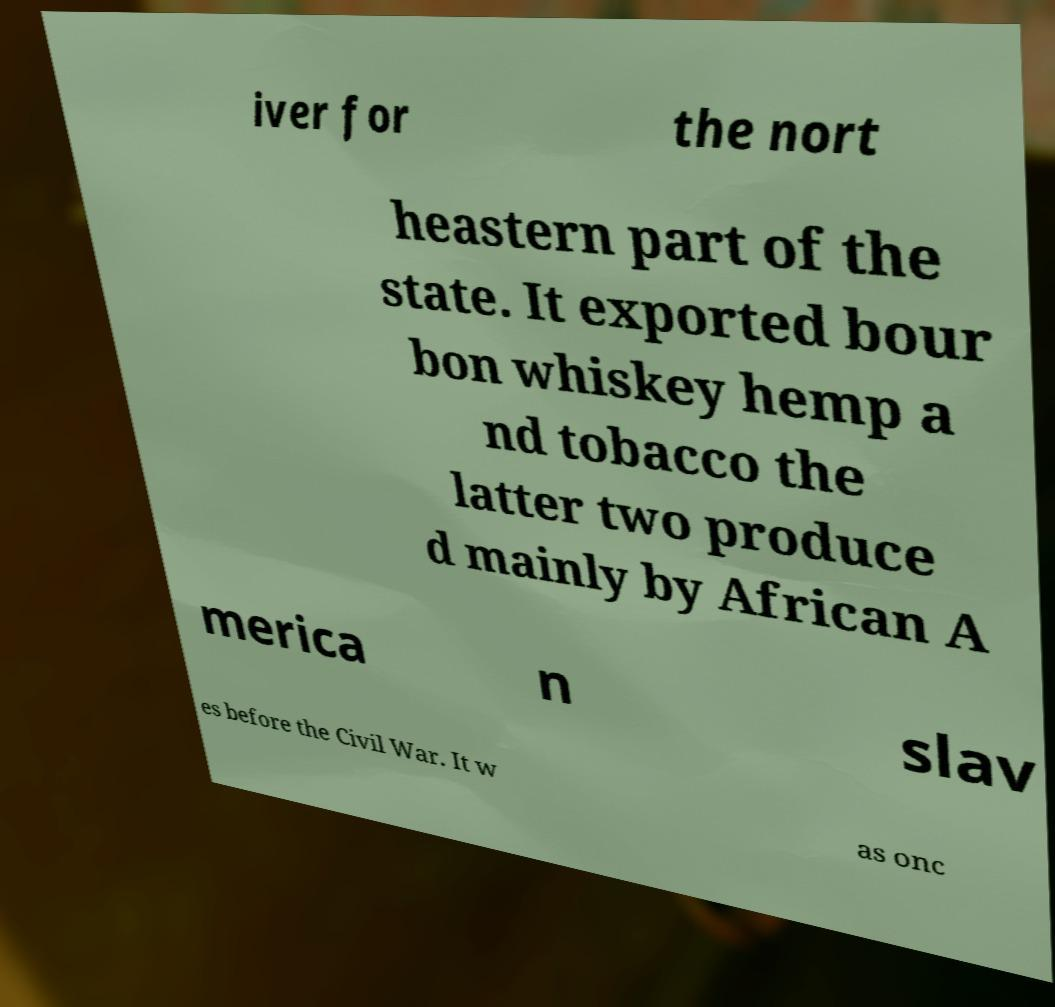Can you read and provide the text displayed in the image?This photo seems to have some interesting text. Can you extract and type it out for me? iver for the nort heastern part of the state. It exported bour bon whiskey hemp a nd tobacco the latter two produce d mainly by African A merica n slav es before the Civil War. It w as onc 